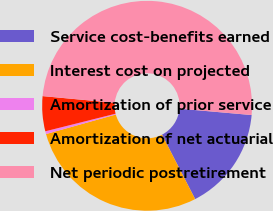<chart> <loc_0><loc_0><loc_500><loc_500><pie_chart><fcel>Service cost-benefits earned<fcel>Interest cost on projected<fcel>Amortization of prior service<fcel>Amortization of net actuarial<fcel>Net periodic postretirement<nl><fcel>16.03%<fcel>28.23%<fcel>0.43%<fcel>5.38%<fcel>49.94%<nl></chart> 